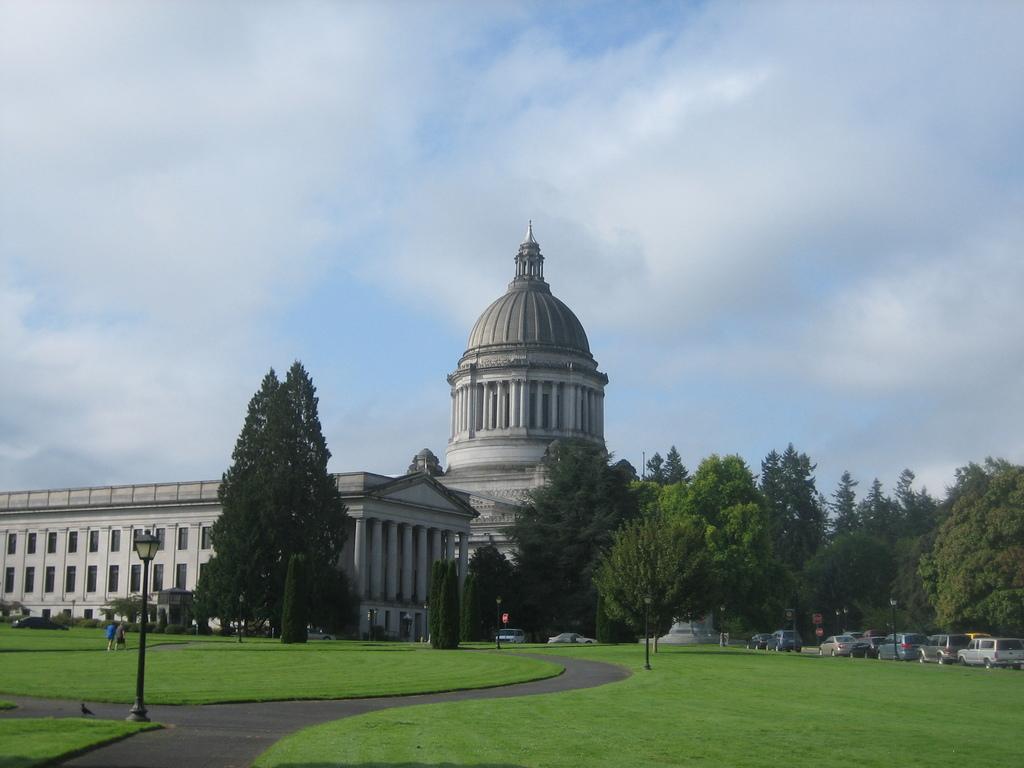How would you summarize this image in a sentence or two? In the foreground of the picture there are street lights, grass, path and a bird. In the center of the picture there are trees, plants, cats and a building. Sky is cloudy. 